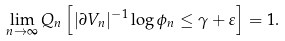Convert formula to latex. <formula><loc_0><loc_0><loc_500><loc_500>\lim _ { n \to \infty } Q _ { n } \left [ | \partial V _ { n } | ^ { - 1 } \log \phi _ { n } \leq \gamma + \varepsilon \right ] = 1 .</formula> 